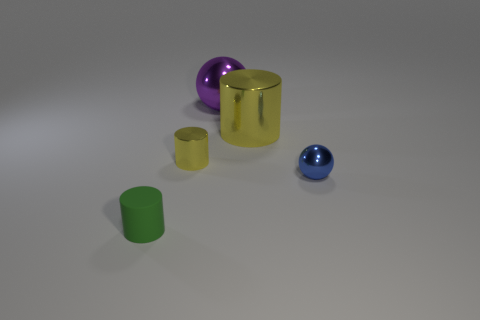Subtract all small green rubber cylinders. How many cylinders are left? 2 Subtract all green cylinders. How many cylinders are left? 2 Subtract 1 spheres. How many spheres are left? 1 Subtract all red cylinders. How many cyan balls are left? 0 Add 2 cyan shiny objects. How many objects exist? 7 Subtract all cylinders. How many objects are left? 2 Add 3 matte cylinders. How many matte cylinders are left? 4 Add 2 gray matte cylinders. How many gray matte cylinders exist? 2 Subtract 0 green spheres. How many objects are left? 5 Subtract all green balls. Subtract all blue cylinders. How many balls are left? 2 